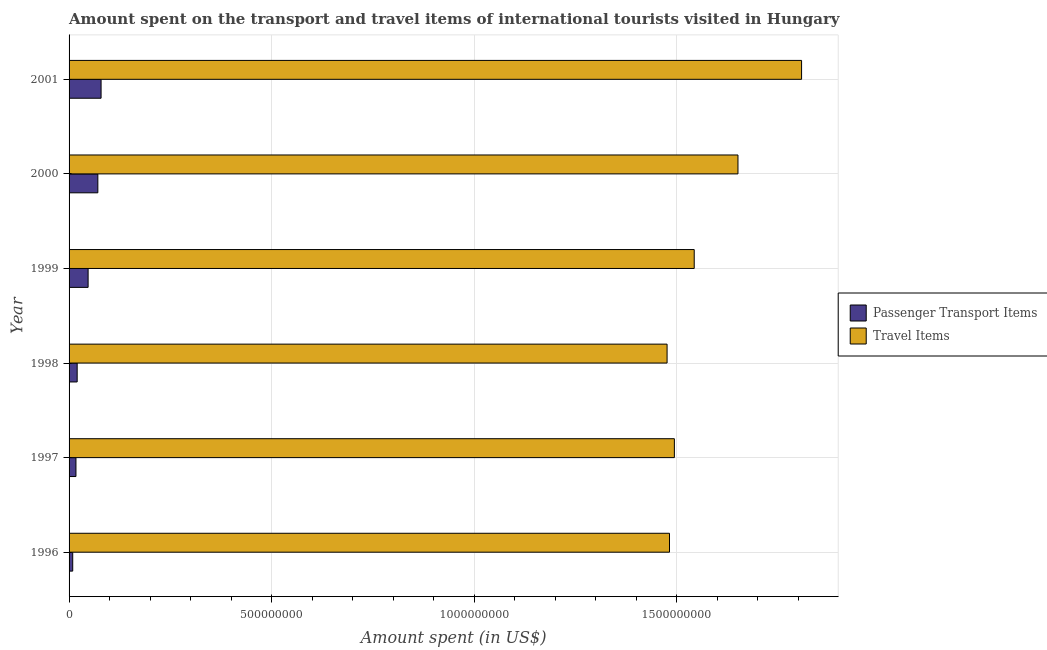Are the number of bars per tick equal to the number of legend labels?
Give a very brief answer. Yes. Are the number of bars on each tick of the Y-axis equal?
Provide a short and direct response. Yes. How many bars are there on the 1st tick from the bottom?
Make the answer very short. 2. What is the amount spent on passenger transport items in 1996?
Offer a very short reply. 9.00e+06. Across all years, what is the maximum amount spent on passenger transport items?
Keep it short and to the point. 7.90e+07. Across all years, what is the minimum amount spent on passenger transport items?
Your response must be concise. 9.00e+06. In which year was the amount spent in travel items maximum?
Your answer should be compact. 2001. In which year was the amount spent on passenger transport items minimum?
Your answer should be very brief. 1996. What is the total amount spent in travel items in the graph?
Provide a short and direct response. 9.45e+09. What is the difference between the amount spent in travel items in 2000 and that in 2001?
Your response must be concise. -1.57e+08. What is the difference between the amount spent in travel items in 1999 and the amount spent on passenger transport items in 1997?
Provide a short and direct response. 1.53e+09. What is the average amount spent in travel items per year?
Offer a terse response. 1.58e+09. In the year 1997, what is the difference between the amount spent on passenger transport items and amount spent in travel items?
Provide a succinct answer. -1.48e+09. In how many years, is the amount spent in travel items greater than 1000000000 US$?
Give a very brief answer. 6. What is the ratio of the amount spent in travel items in 1996 to that in 1999?
Your answer should be compact. 0.96. Is the difference between the amount spent in travel items in 1997 and 1999 greater than the difference between the amount spent on passenger transport items in 1997 and 1999?
Provide a succinct answer. No. What is the difference between the highest and the second highest amount spent in travel items?
Make the answer very short. 1.57e+08. What is the difference between the highest and the lowest amount spent on passenger transport items?
Ensure brevity in your answer.  7.00e+07. Is the sum of the amount spent in travel items in 1998 and 2001 greater than the maximum amount spent on passenger transport items across all years?
Offer a very short reply. Yes. What does the 1st bar from the top in 1996 represents?
Offer a terse response. Travel Items. What does the 1st bar from the bottom in 2000 represents?
Your response must be concise. Passenger Transport Items. Are all the bars in the graph horizontal?
Your answer should be very brief. Yes. What is the difference between two consecutive major ticks on the X-axis?
Ensure brevity in your answer.  5.00e+08. Does the graph contain any zero values?
Provide a succinct answer. No. Where does the legend appear in the graph?
Provide a succinct answer. Center right. What is the title of the graph?
Keep it short and to the point. Amount spent on the transport and travel items of international tourists visited in Hungary. Does "Electricity" appear as one of the legend labels in the graph?
Offer a terse response. No. What is the label or title of the X-axis?
Your response must be concise. Amount spent (in US$). What is the Amount spent (in US$) in Passenger Transport Items in 1996?
Your response must be concise. 9.00e+06. What is the Amount spent (in US$) in Travel Items in 1996?
Your answer should be very brief. 1.48e+09. What is the Amount spent (in US$) in Passenger Transport Items in 1997?
Give a very brief answer. 1.70e+07. What is the Amount spent (in US$) in Travel Items in 1997?
Make the answer very short. 1.49e+09. What is the Amount spent (in US$) in Travel Items in 1998?
Offer a terse response. 1.48e+09. What is the Amount spent (in US$) in Passenger Transport Items in 1999?
Make the answer very short. 4.70e+07. What is the Amount spent (in US$) of Travel Items in 1999?
Your answer should be compact. 1.54e+09. What is the Amount spent (in US$) of Passenger Transport Items in 2000?
Ensure brevity in your answer.  7.10e+07. What is the Amount spent (in US$) of Travel Items in 2000?
Your answer should be compact. 1.65e+09. What is the Amount spent (in US$) of Passenger Transport Items in 2001?
Offer a very short reply. 7.90e+07. What is the Amount spent (in US$) in Travel Items in 2001?
Ensure brevity in your answer.  1.81e+09. Across all years, what is the maximum Amount spent (in US$) in Passenger Transport Items?
Ensure brevity in your answer.  7.90e+07. Across all years, what is the maximum Amount spent (in US$) in Travel Items?
Your answer should be compact. 1.81e+09. Across all years, what is the minimum Amount spent (in US$) of Passenger Transport Items?
Offer a very short reply. 9.00e+06. Across all years, what is the minimum Amount spent (in US$) in Travel Items?
Provide a short and direct response. 1.48e+09. What is the total Amount spent (in US$) in Passenger Transport Items in the graph?
Give a very brief answer. 2.43e+08. What is the total Amount spent (in US$) in Travel Items in the graph?
Make the answer very short. 9.45e+09. What is the difference between the Amount spent (in US$) of Passenger Transport Items in 1996 and that in 1997?
Make the answer very short. -8.00e+06. What is the difference between the Amount spent (in US$) in Travel Items in 1996 and that in 1997?
Keep it short and to the point. -1.20e+07. What is the difference between the Amount spent (in US$) of Passenger Transport Items in 1996 and that in 1998?
Offer a very short reply. -1.10e+07. What is the difference between the Amount spent (in US$) of Passenger Transport Items in 1996 and that in 1999?
Your answer should be very brief. -3.80e+07. What is the difference between the Amount spent (in US$) of Travel Items in 1996 and that in 1999?
Your response must be concise. -6.10e+07. What is the difference between the Amount spent (in US$) of Passenger Transport Items in 1996 and that in 2000?
Give a very brief answer. -6.20e+07. What is the difference between the Amount spent (in US$) of Travel Items in 1996 and that in 2000?
Your response must be concise. -1.69e+08. What is the difference between the Amount spent (in US$) in Passenger Transport Items in 1996 and that in 2001?
Offer a terse response. -7.00e+07. What is the difference between the Amount spent (in US$) of Travel Items in 1996 and that in 2001?
Provide a short and direct response. -3.26e+08. What is the difference between the Amount spent (in US$) in Travel Items in 1997 and that in 1998?
Ensure brevity in your answer.  1.80e+07. What is the difference between the Amount spent (in US$) in Passenger Transport Items in 1997 and that in 1999?
Your response must be concise. -3.00e+07. What is the difference between the Amount spent (in US$) in Travel Items in 1997 and that in 1999?
Your response must be concise. -4.90e+07. What is the difference between the Amount spent (in US$) of Passenger Transport Items in 1997 and that in 2000?
Ensure brevity in your answer.  -5.40e+07. What is the difference between the Amount spent (in US$) of Travel Items in 1997 and that in 2000?
Ensure brevity in your answer.  -1.57e+08. What is the difference between the Amount spent (in US$) of Passenger Transport Items in 1997 and that in 2001?
Your answer should be very brief. -6.20e+07. What is the difference between the Amount spent (in US$) in Travel Items in 1997 and that in 2001?
Offer a very short reply. -3.14e+08. What is the difference between the Amount spent (in US$) in Passenger Transport Items in 1998 and that in 1999?
Ensure brevity in your answer.  -2.70e+07. What is the difference between the Amount spent (in US$) in Travel Items in 1998 and that in 1999?
Offer a terse response. -6.70e+07. What is the difference between the Amount spent (in US$) of Passenger Transport Items in 1998 and that in 2000?
Provide a short and direct response. -5.10e+07. What is the difference between the Amount spent (in US$) in Travel Items in 1998 and that in 2000?
Offer a very short reply. -1.75e+08. What is the difference between the Amount spent (in US$) in Passenger Transport Items in 1998 and that in 2001?
Provide a short and direct response. -5.90e+07. What is the difference between the Amount spent (in US$) in Travel Items in 1998 and that in 2001?
Keep it short and to the point. -3.32e+08. What is the difference between the Amount spent (in US$) of Passenger Transport Items in 1999 and that in 2000?
Give a very brief answer. -2.40e+07. What is the difference between the Amount spent (in US$) of Travel Items in 1999 and that in 2000?
Your response must be concise. -1.08e+08. What is the difference between the Amount spent (in US$) in Passenger Transport Items in 1999 and that in 2001?
Provide a succinct answer. -3.20e+07. What is the difference between the Amount spent (in US$) in Travel Items in 1999 and that in 2001?
Your answer should be compact. -2.65e+08. What is the difference between the Amount spent (in US$) in Passenger Transport Items in 2000 and that in 2001?
Your answer should be compact. -8.00e+06. What is the difference between the Amount spent (in US$) of Travel Items in 2000 and that in 2001?
Make the answer very short. -1.57e+08. What is the difference between the Amount spent (in US$) in Passenger Transport Items in 1996 and the Amount spent (in US$) in Travel Items in 1997?
Make the answer very short. -1.48e+09. What is the difference between the Amount spent (in US$) of Passenger Transport Items in 1996 and the Amount spent (in US$) of Travel Items in 1998?
Your response must be concise. -1.47e+09. What is the difference between the Amount spent (in US$) in Passenger Transport Items in 1996 and the Amount spent (in US$) in Travel Items in 1999?
Make the answer very short. -1.53e+09. What is the difference between the Amount spent (in US$) in Passenger Transport Items in 1996 and the Amount spent (in US$) in Travel Items in 2000?
Your answer should be compact. -1.64e+09. What is the difference between the Amount spent (in US$) in Passenger Transport Items in 1996 and the Amount spent (in US$) in Travel Items in 2001?
Keep it short and to the point. -1.80e+09. What is the difference between the Amount spent (in US$) of Passenger Transport Items in 1997 and the Amount spent (in US$) of Travel Items in 1998?
Provide a short and direct response. -1.46e+09. What is the difference between the Amount spent (in US$) of Passenger Transport Items in 1997 and the Amount spent (in US$) of Travel Items in 1999?
Give a very brief answer. -1.53e+09. What is the difference between the Amount spent (in US$) in Passenger Transport Items in 1997 and the Amount spent (in US$) in Travel Items in 2000?
Give a very brief answer. -1.63e+09. What is the difference between the Amount spent (in US$) in Passenger Transport Items in 1997 and the Amount spent (in US$) in Travel Items in 2001?
Offer a very short reply. -1.79e+09. What is the difference between the Amount spent (in US$) of Passenger Transport Items in 1998 and the Amount spent (in US$) of Travel Items in 1999?
Your response must be concise. -1.52e+09. What is the difference between the Amount spent (in US$) of Passenger Transport Items in 1998 and the Amount spent (in US$) of Travel Items in 2000?
Your response must be concise. -1.63e+09. What is the difference between the Amount spent (in US$) of Passenger Transport Items in 1998 and the Amount spent (in US$) of Travel Items in 2001?
Keep it short and to the point. -1.79e+09. What is the difference between the Amount spent (in US$) of Passenger Transport Items in 1999 and the Amount spent (in US$) of Travel Items in 2000?
Your answer should be compact. -1.60e+09. What is the difference between the Amount spent (in US$) of Passenger Transport Items in 1999 and the Amount spent (in US$) of Travel Items in 2001?
Your answer should be very brief. -1.76e+09. What is the difference between the Amount spent (in US$) in Passenger Transport Items in 2000 and the Amount spent (in US$) in Travel Items in 2001?
Keep it short and to the point. -1.74e+09. What is the average Amount spent (in US$) in Passenger Transport Items per year?
Give a very brief answer. 4.05e+07. What is the average Amount spent (in US$) in Travel Items per year?
Offer a terse response. 1.58e+09. In the year 1996, what is the difference between the Amount spent (in US$) in Passenger Transport Items and Amount spent (in US$) in Travel Items?
Keep it short and to the point. -1.47e+09. In the year 1997, what is the difference between the Amount spent (in US$) in Passenger Transport Items and Amount spent (in US$) in Travel Items?
Ensure brevity in your answer.  -1.48e+09. In the year 1998, what is the difference between the Amount spent (in US$) in Passenger Transport Items and Amount spent (in US$) in Travel Items?
Provide a succinct answer. -1.46e+09. In the year 1999, what is the difference between the Amount spent (in US$) of Passenger Transport Items and Amount spent (in US$) of Travel Items?
Your answer should be compact. -1.50e+09. In the year 2000, what is the difference between the Amount spent (in US$) in Passenger Transport Items and Amount spent (in US$) in Travel Items?
Ensure brevity in your answer.  -1.58e+09. In the year 2001, what is the difference between the Amount spent (in US$) in Passenger Transport Items and Amount spent (in US$) in Travel Items?
Keep it short and to the point. -1.73e+09. What is the ratio of the Amount spent (in US$) of Passenger Transport Items in 1996 to that in 1997?
Your answer should be very brief. 0.53. What is the ratio of the Amount spent (in US$) in Passenger Transport Items in 1996 to that in 1998?
Provide a short and direct response. 0.45. What is the ratio of the Amount spent (in US$) of Passenger Transport Items in 1996 to that in 1999?
Your response must be concise. 0.19. What is the ratio of the Amount spent (in US$) in Travel Items in 1996 to that in 1999?
Give a very brief answer. 0.96. What is the ratio of the Amount spent (in US$) in Passenger Transport Items in 1996 to that in 2000?
Give a very brief answer. 0.13. What is the ratio of the Amount spent (in US$) in Travel Items in 1996 to that in 2000?
Give a very brief answer. 0.9. What is the ratio of the Amount spent (in US$) of Passenger Transport Items in 1996 to that in 2001?
Your answer should be very brief. 0.11. What is the ratio of the Amount spent (in US$) in Travel Items in 1996 to that in 2001?
Offer a terse response. 0.82. What is the ratio of the Amount spent (in US$) in Travel Items in 1997 to that in 1998?
Keep it short and to the point. 1.01. What is the ratio of the Amount spent (in US$) in Passenger Transport Items in 1997 to that in 1999?
Provide a short and direct response. 0.36. What is the ratio of the Amount spent (in US$) of Travel Items in 1997 to that in 1999?
Your answer should be very brief. 0.97. What is the ratio of the Amount spent (in US$) in Passenger Transport Items in 1997 to that in 2000?
Offer a terse response. 0.24. What is the ratio of the Amount spent (in US$) of Travel Items in 1997 to that in 2000?
Ensure brevity in your answer.  0.9. What is the ratio of the Amount spent (in US$) of Passenger Transport Items in 1997 to that in 2001?
Provide a short and direct response. 0.22. What is the ratio of the Amount spent (in US$) in Travel Items in 1997 to that in 2001?
Offer a very short reply. 0.83. What is the ratio of the Amount spent (in US$) of Passenger Transport Items in 1998 to that in 1999?
Ensure brevity in your answer.  0.43. What is the ratio of the Amount spent (in US$) in Travel Items in 1998 to that in 1999?
Your response must be concise. 0.96. What is the ratio of the Amount spent (in US$) of Passenger Transport Items in 1998 to that in 2000?
Give a very brief answer. 0.28. What is the ratio of the Amount spent (in US$) in Travel Items in 1998 to that in 2000?
Provide a succinct answer. 0.89. What is the ratio of the Amount spent (in US$) of Passenger Transport Items in 1998 to that in 2001?
Make the answer very short. 0.25. What is the ratio of the Amount spent (in US$) of Travel Items in 1998 to that in 2001?
Make the answer very short. 0.82. What is the ratio of the Amount spent (in US$) in Passenger Transport Items in 1999 to that in 2000?
Offer a terse response. 0.66. What is the ratio of the Amount spent (in US$) of Travel Items in 1999 to that in 2000?
Your answer should be compact. 0.93. What is the ratio of the Amount spent (in US$) in Passenger Transport Items in 1999 to that in 2001?
Give a very brief answer. 0.59. What is the ratio of the Amount spent (in US$) in Travel Items in 1999 to that in 2001?
Your answer should be very brief. 0.85. What is the ratio of the Amount spent (in US$) of Passenger Transport Items in 2000 to that in 2001?
Your response must be concise. 0.9. What is the ratio of the Amount spent (in US$) in Travel Items in 2000 to that in 2001?
Your response must be concise. 0.91. What is the difference between the highest and the second highest Amount spent (in US$) in Passenger Transport Items?
Offer a very short reply. 8.00e+06. What is the difference between the highest and the second highest Amount spent (in US$) of Travel Items?
Your answer should be compact. 1.57e+08. What is the difference between the highest and the lowest Amount spent (in US$) in Passenger Transport Items?
Offer a terse response. 7.00e+07. What is the difference between the highest and the lowest Amount spent (in US$) in Travel Items?
Your response must be concise. 3.32e+08. 